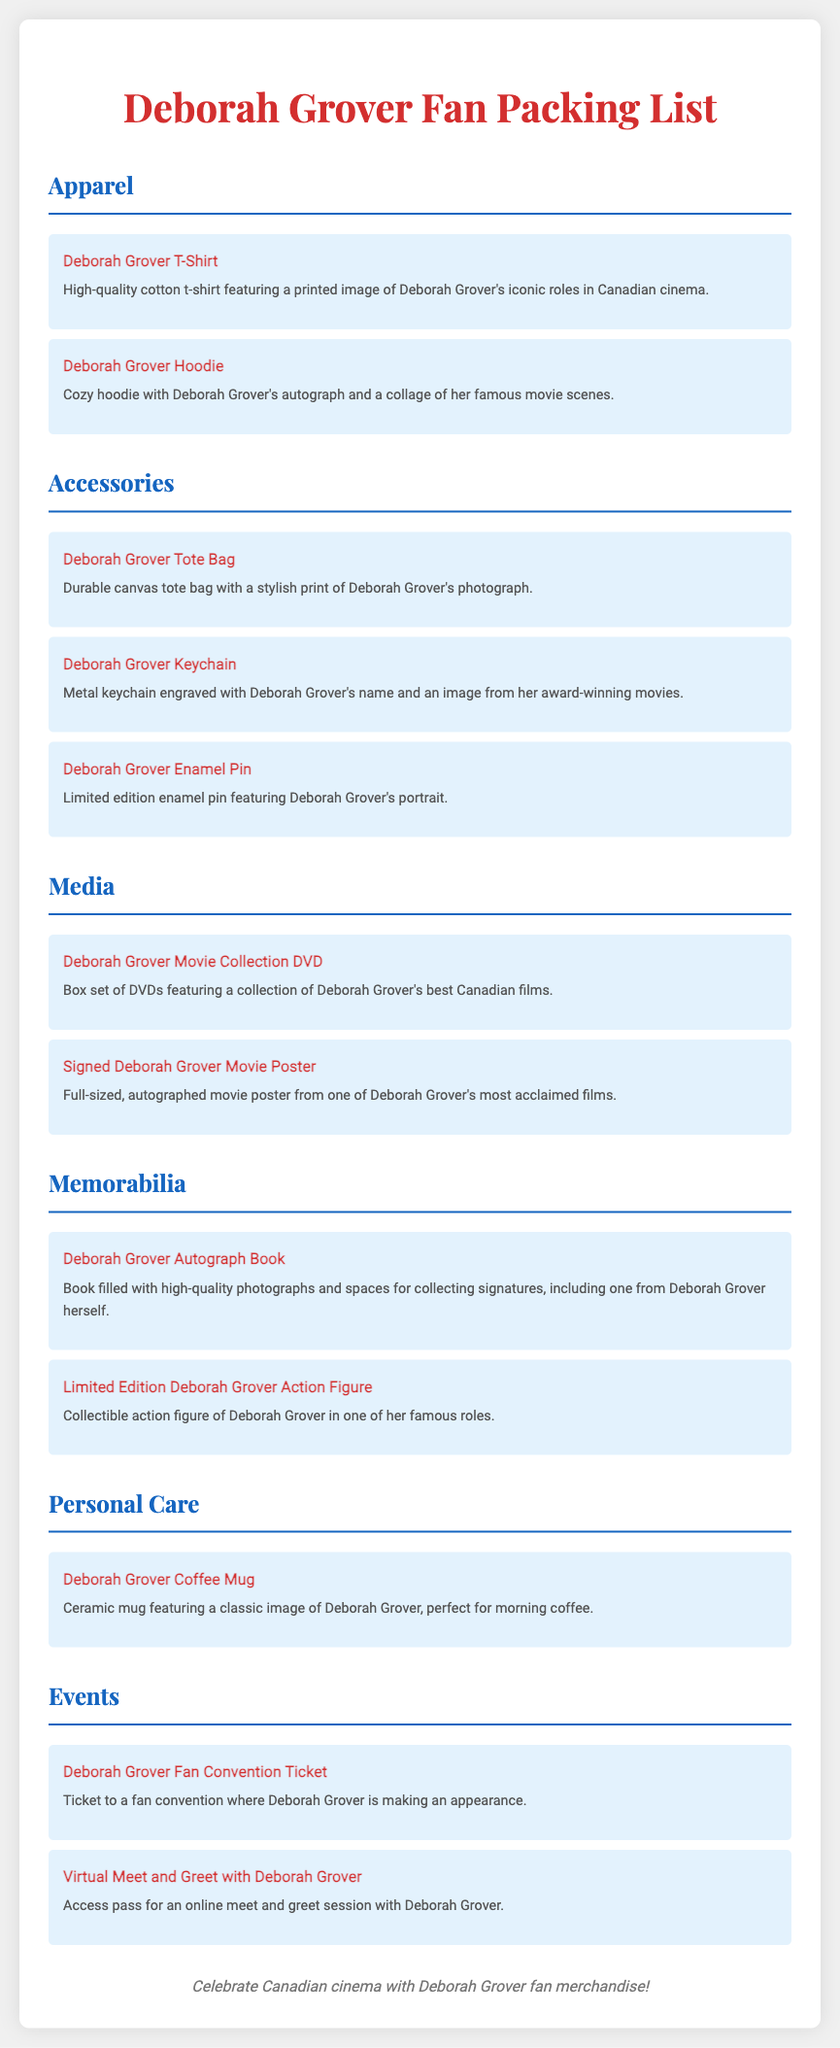What merchandise categories are listed in the document? The document includes categories such as Apparel, Accessories, Media, Memorabilia, Personal Care, and Events.
Answer: Apparel, Accessories, Media, Memorabilia, Personal Care, Events What item features Deborah Grover's autograph? The cozy hoodie is described as having Deborah Grover's autograph alongside a collage of her famous movie scenes.
Answer: Hoodie How many types of accessories are mentioned in the list? The accessories section includes three items: Tote Bag, Keychain, and Enamel Pin.
Answer: Three What is included in the Media category? The Media category includes items like a DVD box set and a signed movie poster.
Answer: DVD Collection, Movie Poster What type of event ticket is listed in the document? The document mentions a ticket to a fan convention where Deborah Grover is making an appearance.
Answer: Fan Convention Ticket Which item is specifically designed for drink usage? The document lists a ceramic coffee mug featuring an image of Deborah Grover.
Answer: Coffee Mug What type of figure is included in the Memorabilia section? The limited edition item mentioned is an action figure of Deborah Grover in one of her famous roles.
Answer: Action Figure What describes the Deborah Grover Tote Bag? It is described in the document as a durable canvas tote bag with a stylish print of Deborah Grover's photograph.
Answer: Durable canvas tote bag What is the purpose of the Deborah Grover Autograph Book? The autograph book is designed for collecting signatures and includes high-quality photographs.
Answer: Collecting signatures 